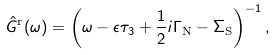<formula> <loc_0><loc_0><loc_500><loc_500>\hat { G } ^ { \text {r} } ( \omega ) = \left ( \omega - \epsilon \tau _ { 3 } + \frac { 1 } { 2 } i \Gamma _ { \text {N} } - \Sigma _ { \text {S} } \right ) ^ { - 1 } ,</formula> 